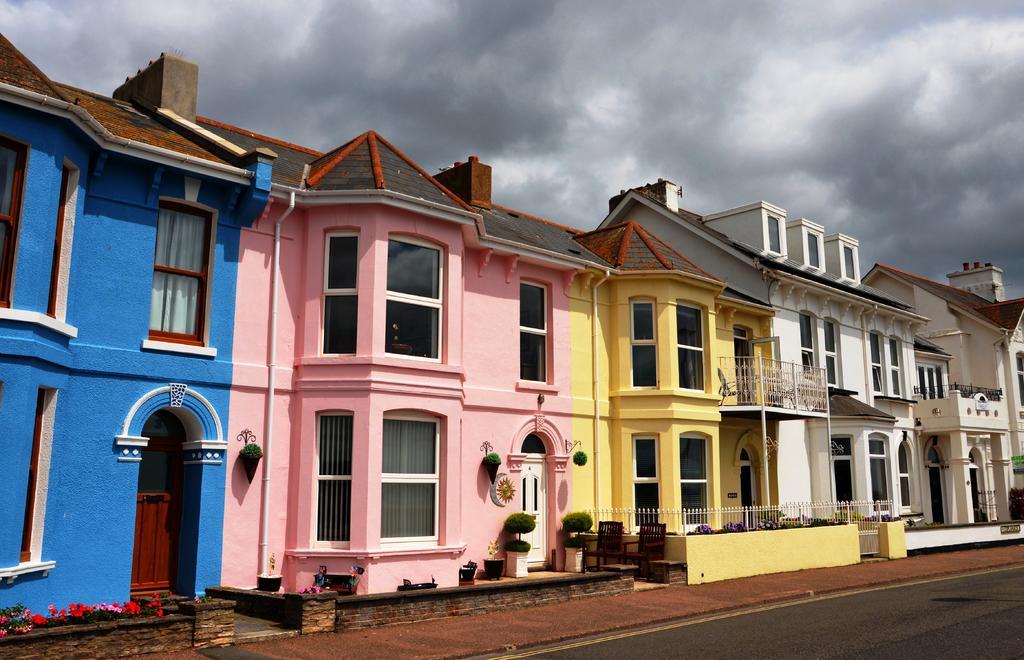Please provide a concise description of this image. In this image, we can see roof houses and plants. There is road in the bottom right of the image. There are clouds in the sky. 